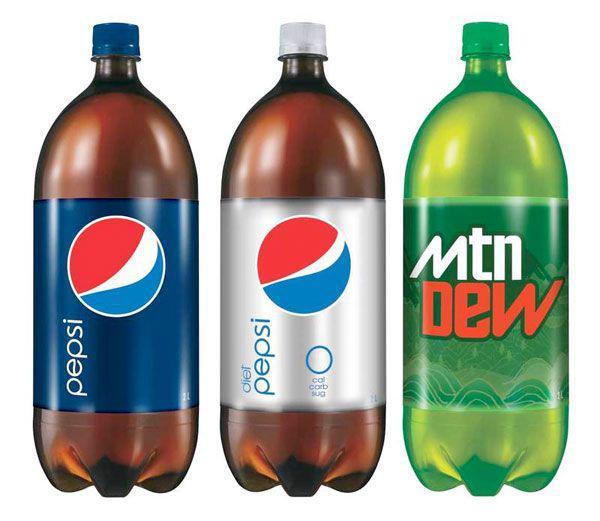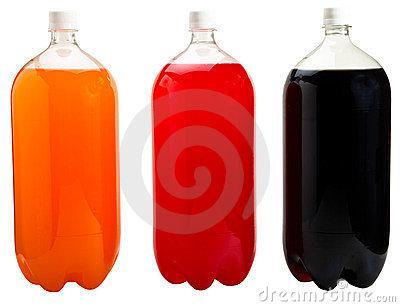The first image is the image on the left, the second image is the image on the right. For the images displayed, is the sentence "Three 2 liter soda bottles have no labels." factually correct? Answer yes or no. Yes. The first image is the image on the left, the second image is the image on the right. Evaluate the accuracy of this statement regarding the images: "No image includes a label with printing on it, and one image contains a straight row of at least four bottles of different colored liquids.". Is it true? Answer yes or no. No. 